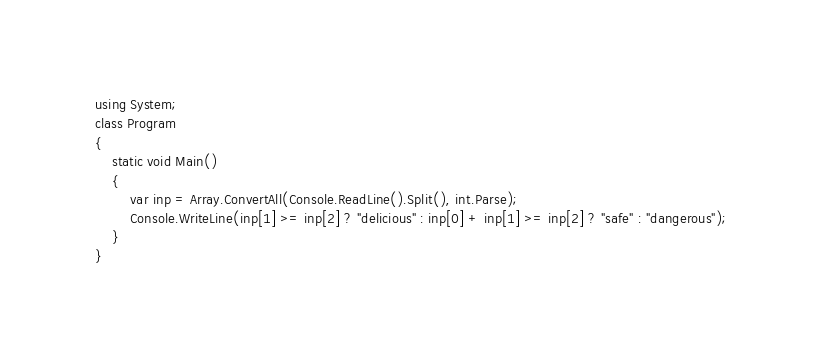Convert code to text. <code><loc_0><loc_0><loc_500><loc_500><_C#_>using System;
class Program
{
    static void Main()
    {
        var inp = Array.ConvertAll(Console.ReadLine().Split(), int.Parse);
        Console.WriteLine(inp[1] >= inp[2] ? "delicious" : inp[0] + inp[1] >= inp[2] ? "safe" : "dangerous");
    }
}
</code> 